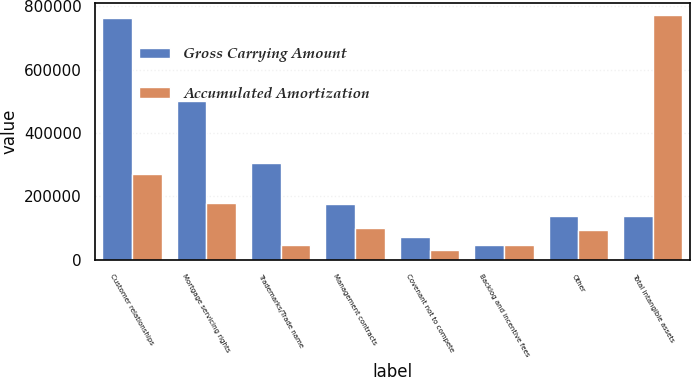<chart> <loc_0><loc_0><loc_500><loc_500><stacked_bar_chart><ecel><fcel>Customer relationships<fcel>Mortgage servicing rights<fcel>Trademarks/Trade name<fcel>Management contracts<fcel>Covenant not to compete<fcel>Backlog and incentive fees<fcel>Other<fcel>Total intangible assets<nl><fcel>Gross Carrying Amount<fcel>761290<fcel>501087<fcel>306559<fcel>177014<fcel>73750<fcel>48445<fcel>138312<fcel>138312<nl><fcel>Accumulated Amortization<fcel>270447<fcel>180563<fcel>46837<fcel>99733<fcel>32777<fcel>48445<fcel>92871<fcel>771673<nl></chart> 